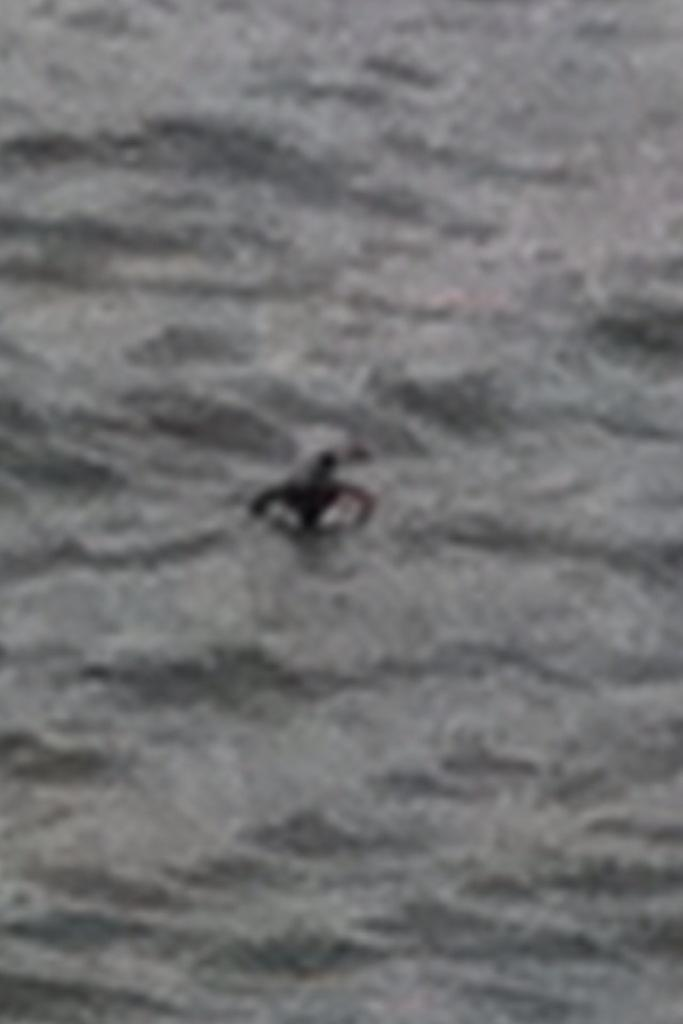What is located in the water in the image? There is an object in the water in the image. What type of doctor is attending to the patient in the image? There is no doctor or patient present in the image; it only features an object in the water. 